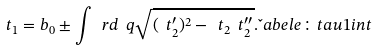<formula> <loc_0><loc_0><loc_500><loc_500>\ t _ { 1 } = b _ { 0 } \pm \int \ r d \ q \sqrt { ( \ t _ { 2 } ^ { \prime } ) ^ { 2 } - \ t _ { 2 } \ t _ { 2 } ^ { \prime \prime } } . \L a b e l { e \colon t a u 1 i n t }</formula> 